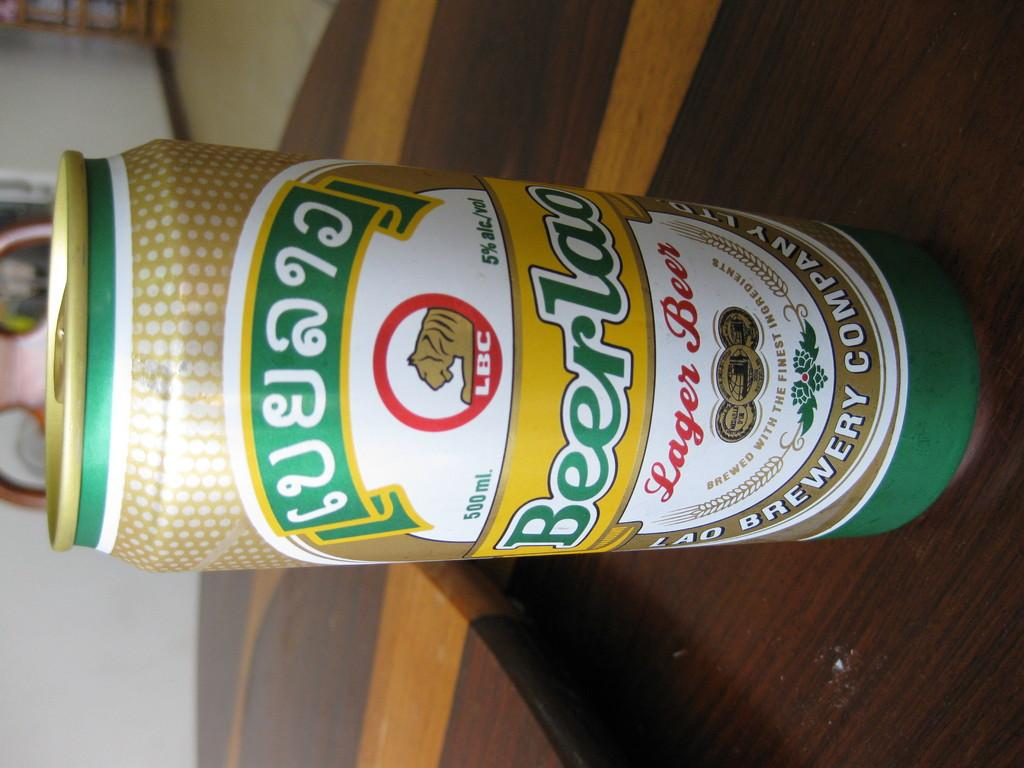Provide a one-sentence caption for the provided image. A can of lager beer has an LBC logo at the top. 